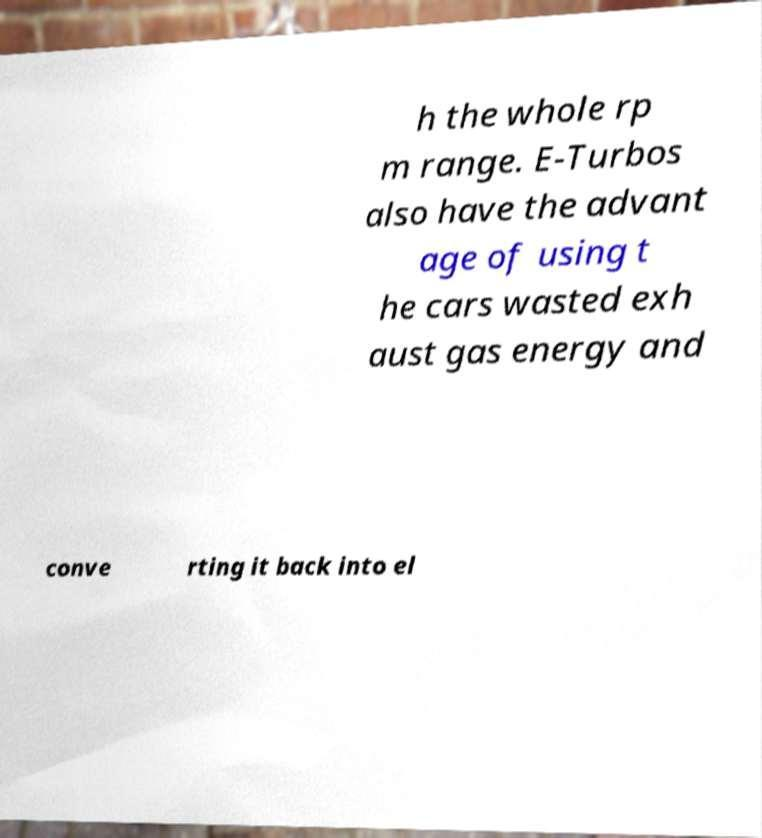There's text embedded in this image that I need extracted. Can you transcribe it verbatim? h the whole rp m range. E-Turbos also have the advant age of using t he cars wasted exh aust gas energy and conve rting it back into el 